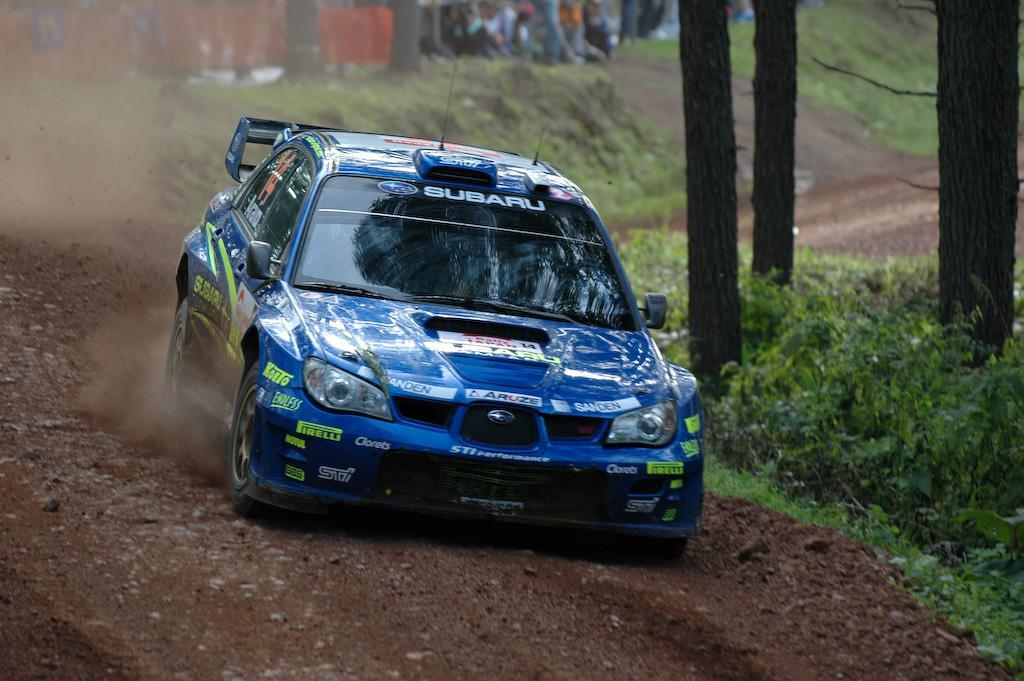What is the main subject in the center of the image? There is a car in the center of the image. What can be seen in the background of the image? There are trees and people in the background of the image. What is visible at the bottom of the image? The ground is visible at the bottom of the image. How many pigs are being sorted by the kettle in the image? There are no pigs or kettles present in the image. 